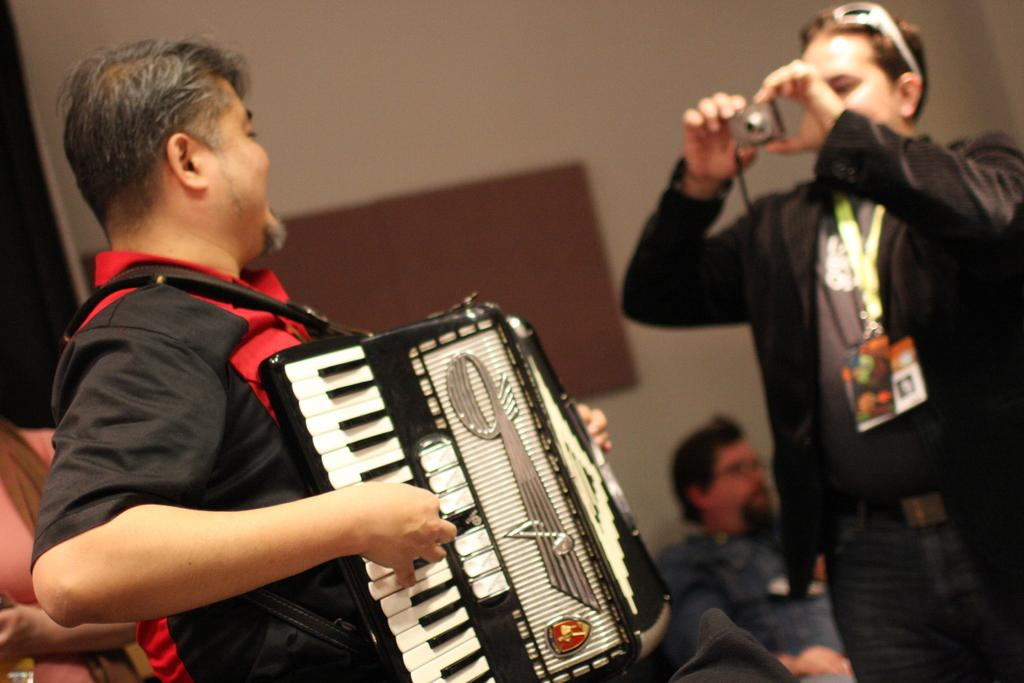What is the main activity being performed by a person in the image? There is a person playing a harmonium in the image. What is another person holding in the image? There is a person holding a camera in the image. Can you describe the setting of the image? There are background people visible in the image, and there is a wall in the background. What type of dirt can be seen on the floor in the image? There is no dirt visible on the floor in the image. Can you describe the house in the image? There is no house present in the image. 